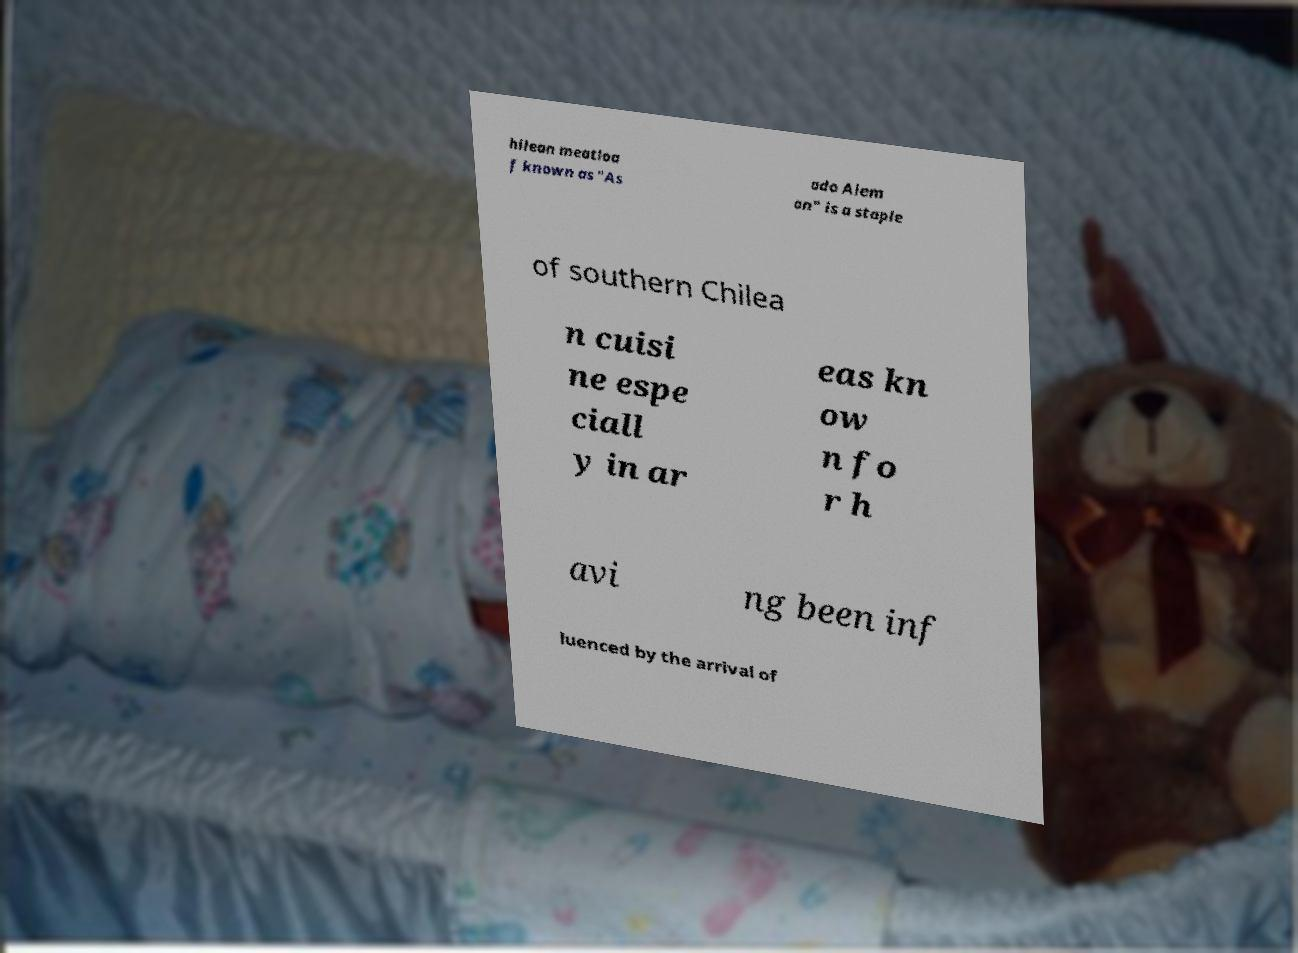There's text embedded in this image that I need extracted. Can you transcribe it verbatim? hilean meatloa f known as "As ado Alem an" is a staple of southern Chilea n cuisi ne espe ciall y in ar eas kn ow n fo r h avi ng been inf luenced by the arrival of 